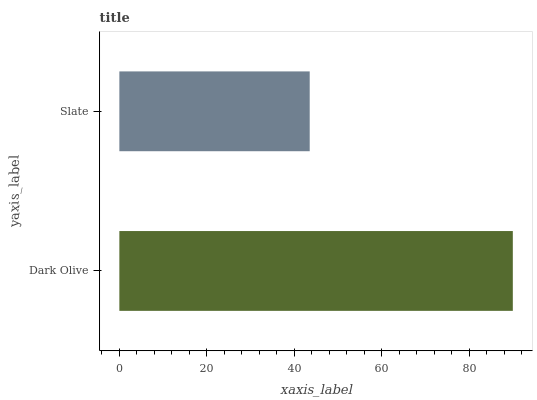Is Slate the minimum?
Answer yes or no. Yes. Is Dark Olive the maximum?
Answer yes or no. Yes. Is Slate the maximum?
Answer yes or no. No. Is Dark Olive greater than Slate?
Answer yes or no. Yes. Is Slate less than Dark Olive?
Answer yes or no. Yes. Is Slate greater than Dark Olive?
Answer yes or no. No. Is Dark Olive less than Slate?
Answer yes or no. No. Is Dark Olive the high median?
Answer yes or no. Yes. Is Slate the low median?
Answer yes or no. Yes. Is Slate the high median?
Answer yes or no. No. Is Dark Olive the low median?
Answer yes or no. No. 